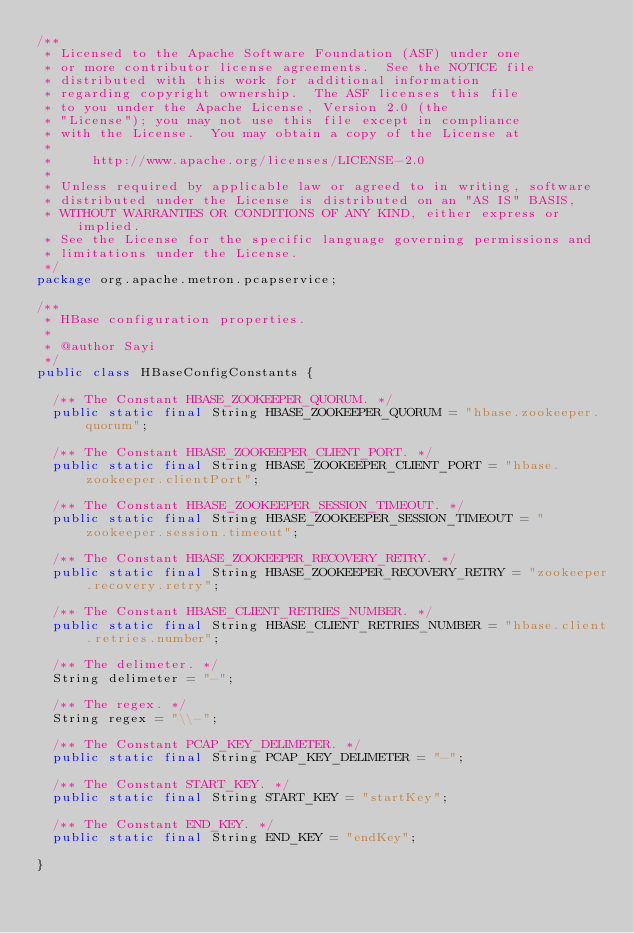Convert code to text. <code><loc_0><loc_0><loc_500><loc_500><_Java_>/**
 * Licensed to the Apache Software Foundation (ASF) under one
 * or more contributor license agreements.  See the NOTICE file
 * distributed with this work for additional information
 * regarding copyright ownership.  The ASF licenses this file
 * to you under the Apache License, Version 2.0 (the
 * "License"); you may not use this file except in compliance
 * with the License.  You may obtain a copy of the License at
 *
 *     http://www.apache.org/licenses/LICENSE-2.0
 *
 * Unless required by applicable law or agreed to in writing, software
 * distributed under the License is distributed on an "AS IS" BASIS,
 * WITHOUT WARRANTIES OR CONDITIONS OF ANY KIND, either express or implied.
 * See the License for the specific language governing permissions and
 * limitations under the License.
 */
package org.apache.metron.pcapservice;

/**
 * HBase configuration properties.
 * 
 * @author Sayi
 */
public class HBaseConfigConstants {

  /** The Constant HBASE_ZOOKEEPER_QUORUM. */
  public static final String HBASE_ZOOKEEPER_QUORUM = "hbase.zookeeper.quorum";

  /** The Constant HBASE_ZOOKEEPER_CLIENT_PORT. */
  public static final String HBASE_ZOOKEEPER_CLIENT_PORT = "hbase.zookeeper.clientPort";

  /** The Constant HBASE_ZOOKEEPER_SESSION_TIMEOUT. */
  public static final String HBASE_ZOOKEEPER_SESSION_TIMEOUT = "zookeeper.session.timeout";

  /** The Constant HBASE_ZOOKEEPER_RECOVERY_RETRY. */
  public static final String HBASE_ZOOKEEPER_RECOVERY_RETRY = "zookeeper.recovery.retry";

  /** The Constant HBASE_CLIENT_RETRIES_NUMBER. */
  public static final String HBASE_CLIENT_RETRIES_NUMBER = "hbase.client.retries.number";

  /** The delimeter. */
  String delimeter = "-";

  /** The regex. */
  String regex = "\\-";

  /** The Constant PCAP_KEY_DELIMETER. */
  public static final String PCAP_KEY_DELIMETER = "-";

  /** The Constant START_KEY. */
  public static final String START_KEY = "startKey";

  /** The Constant END_KEY. */
  public static final String END_KEY = "endKey";

}
</code> 